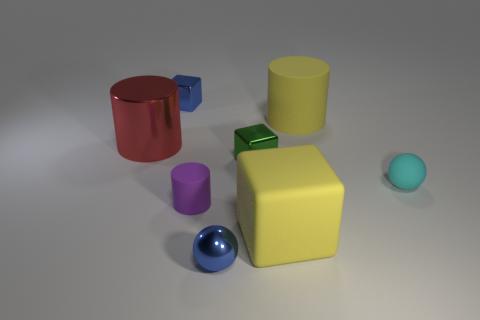Add 1 red metallic objects. How many objects exist? 9 Subtract all cubes. How many objects are left? 5 Add 1 small cyan matte spheres. How many small cyan matte spheres are left? 2 Add 5 big cyan cylinders. How many big cyan cylinders exist? 5 Subtract 0 red balls. How many objects are left? 8 Subtract all red metal cylinders. Subtract all yellow rubber cylinders. How many objects are left? 6 